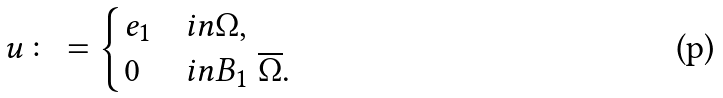Convert formula to latex. <formula><loc_0><loc_0><loc_500><loc_500>u \colon = \begin{cases} { e } _ { 1 } & i n \Omega , \\ 0 & i n B _ { 1 } \ \overline { \Omega } . \end{cases}</formula> 